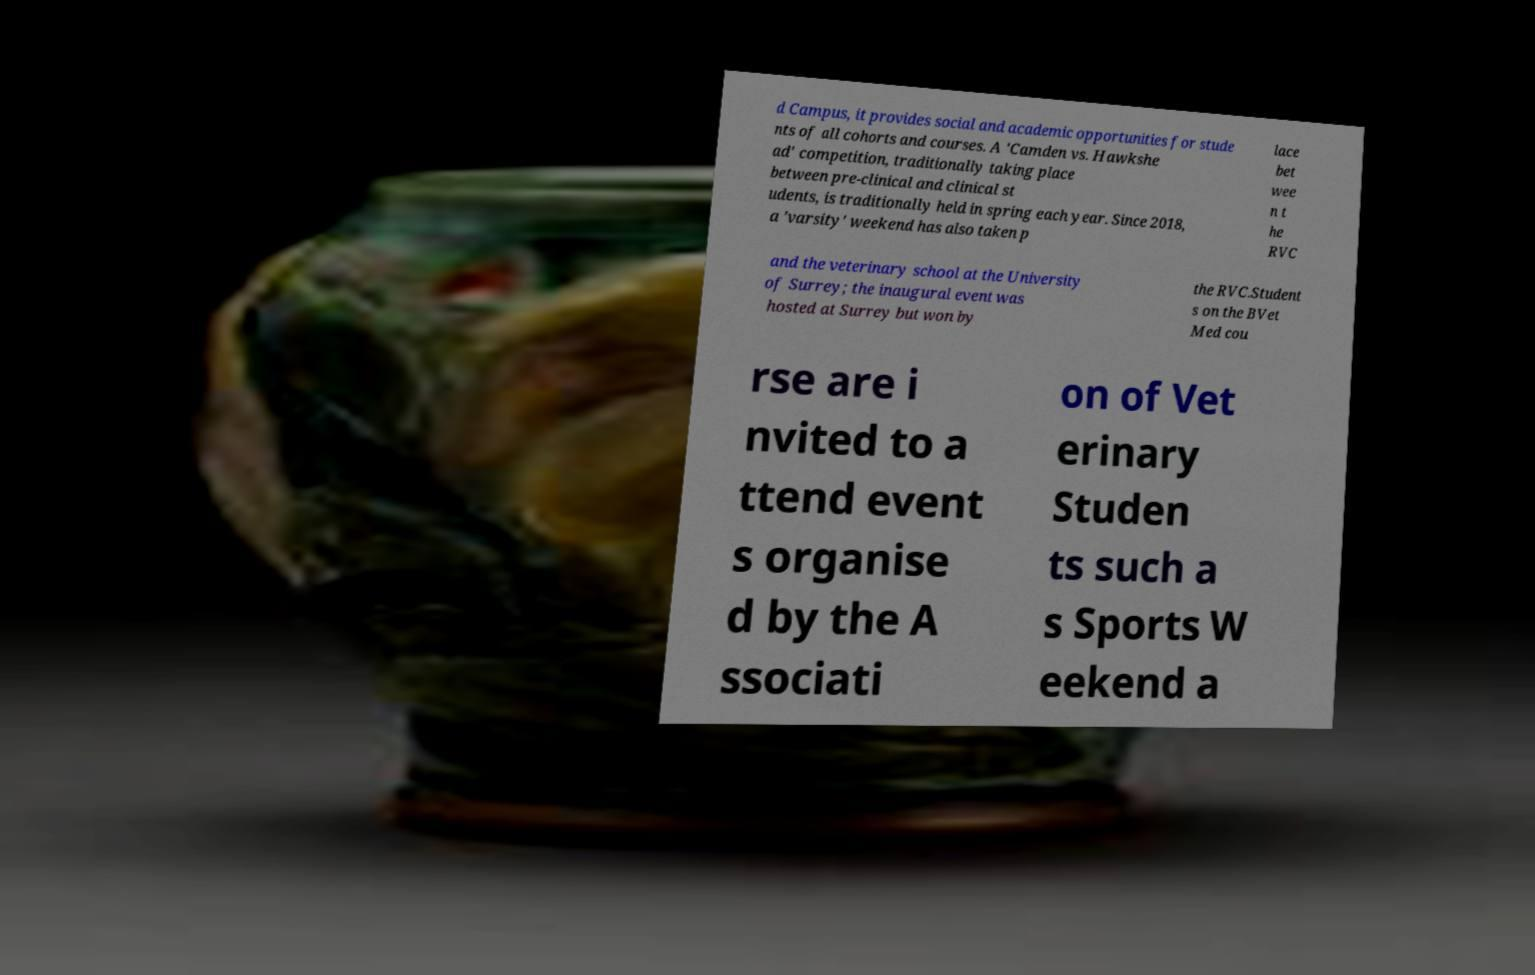Can you accurately transcribe the text from the provided image for me? d Campus, it provides social and academic opportunities for stude nts of all cohorts and courses. A 'Camden vs. Hawkshe ad' competition, traditionally taking place between pre-clinical and clinical st udents, is traditionally held in spring each year. Since 2018, a 'varsity' weekend has also taken p lace bet wee n t he RVC and the veterinary school at the University of Surrey; the inaugural event was hosted at Surrey but won by the RVC.Student s on the BVet Med cou rse are i nvited to a ttend event s organise d by the A ssociati on of Vet erinary Studen ts such a s Sports W eekend a 